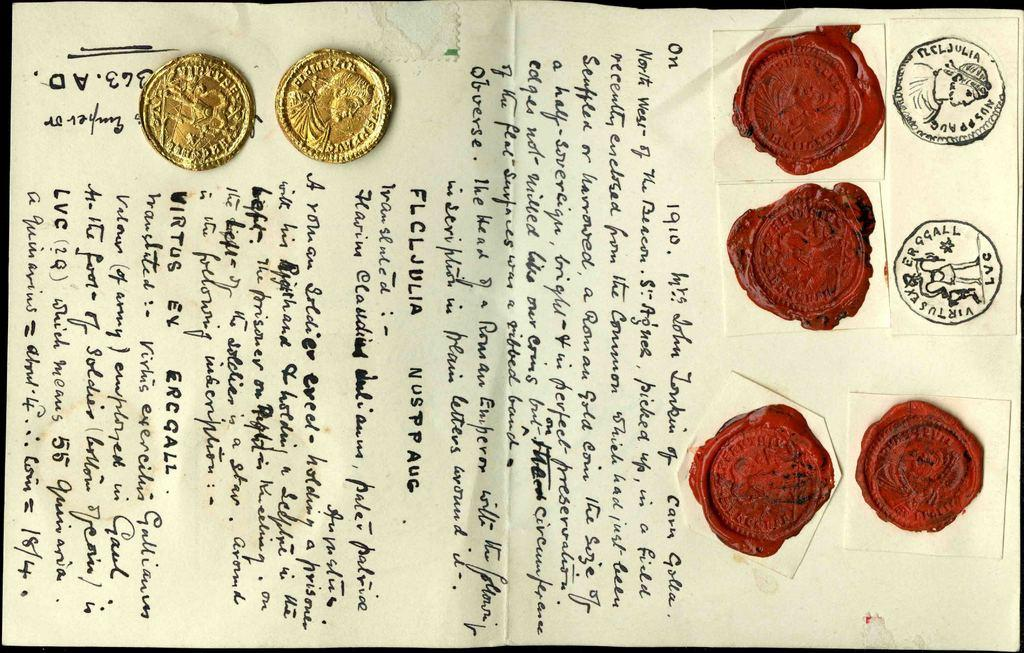What is present on the paper in the image? There is text on the paper, as well as coins and wax stamps. Where are the coins located on the paper? The coins are on the paper in the top left corner. What is located to the right of the coins on the paper? There are wax stamps on the paper to the right of the coins. Can you describe the car parked next to the paper in the image? There is no car present in the image; it only features a paper with text, coins, and wax stamps. 